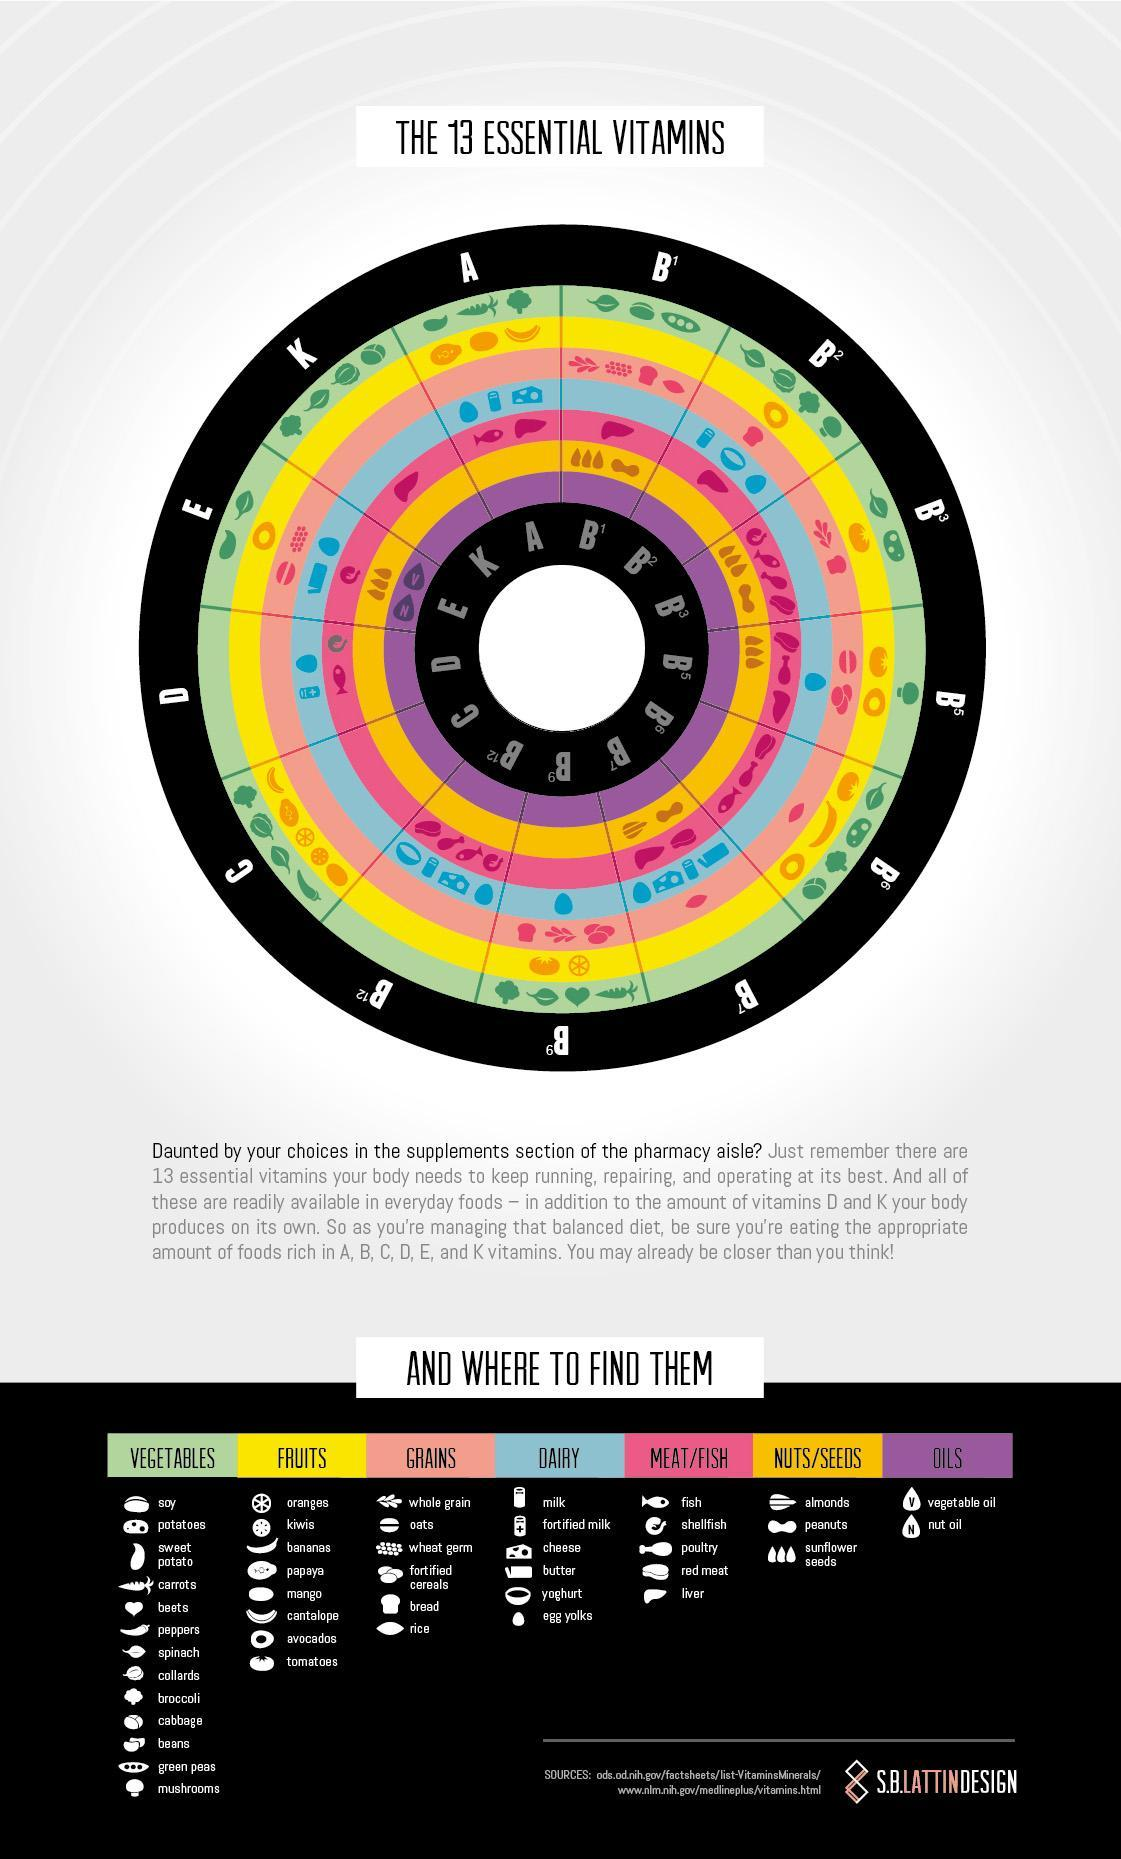Which vegetable is a source of vitamin B5?
Answer the question with a short phrase. mushroom Which grain item gets you vitamin b2? bread Vegetable oil and nut oil is a source of which vitamin? E How many types of oils are listed here? 2 Which fruit has vitamin b2? avocados Which fish/meat item is a source of vitamin k? liver Which grain is a source of vitamin b5 and b7? rice Which fish/meat item is a source of vitamin E? shellfish Apart from butter which dairy product is a source of vitamin e? egg yolks Which dairy item is a source of vitamin b9? egg yolks Which vitamin do you get from cantalope, papaya, kiwis, orange and mango? C Apart from egg yolks, which dairy item is a source of vitamin D? fortified milk LIver is a source of how many of the vitamins shown here? 6 How many meat/fish item are listed here? 5 Which fruit is a source of vitamin E? avocado Which is the vitamin you ll get from 4 of the 5 fish/meat items listed here? vitamin b3 